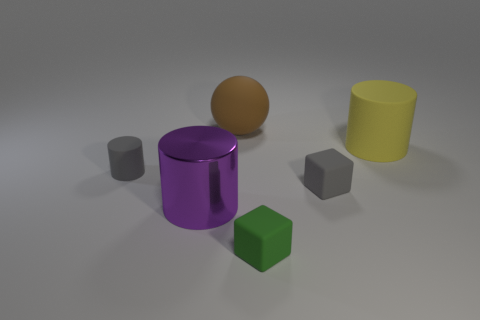What does this assortment of objects suggest about the image's purpose? This image appears to serve an illustrative purpose, showcasing a variety of simple 3D shapes and colors, which might be used in a tutorial for modeling or rendering in computer graphics. The arrangement and lighting seem intentionally simplistic to possibly teach concepts such as shading, color harmony, and spatial arrangement without any distractions. How might lighting affect the perception of these objects? The soft and diffused lighting in the scene provides a gentle showcase of each object's dimensionality with subtle shadows, allowing an observer to better perceive their forms. Harsher lighting could create more dramatic shadows and highlights, which may alter the perception of shape and depth, whereas the current lighting maintains a balance that is aesthetically pleasing and clear for educational purposes. 